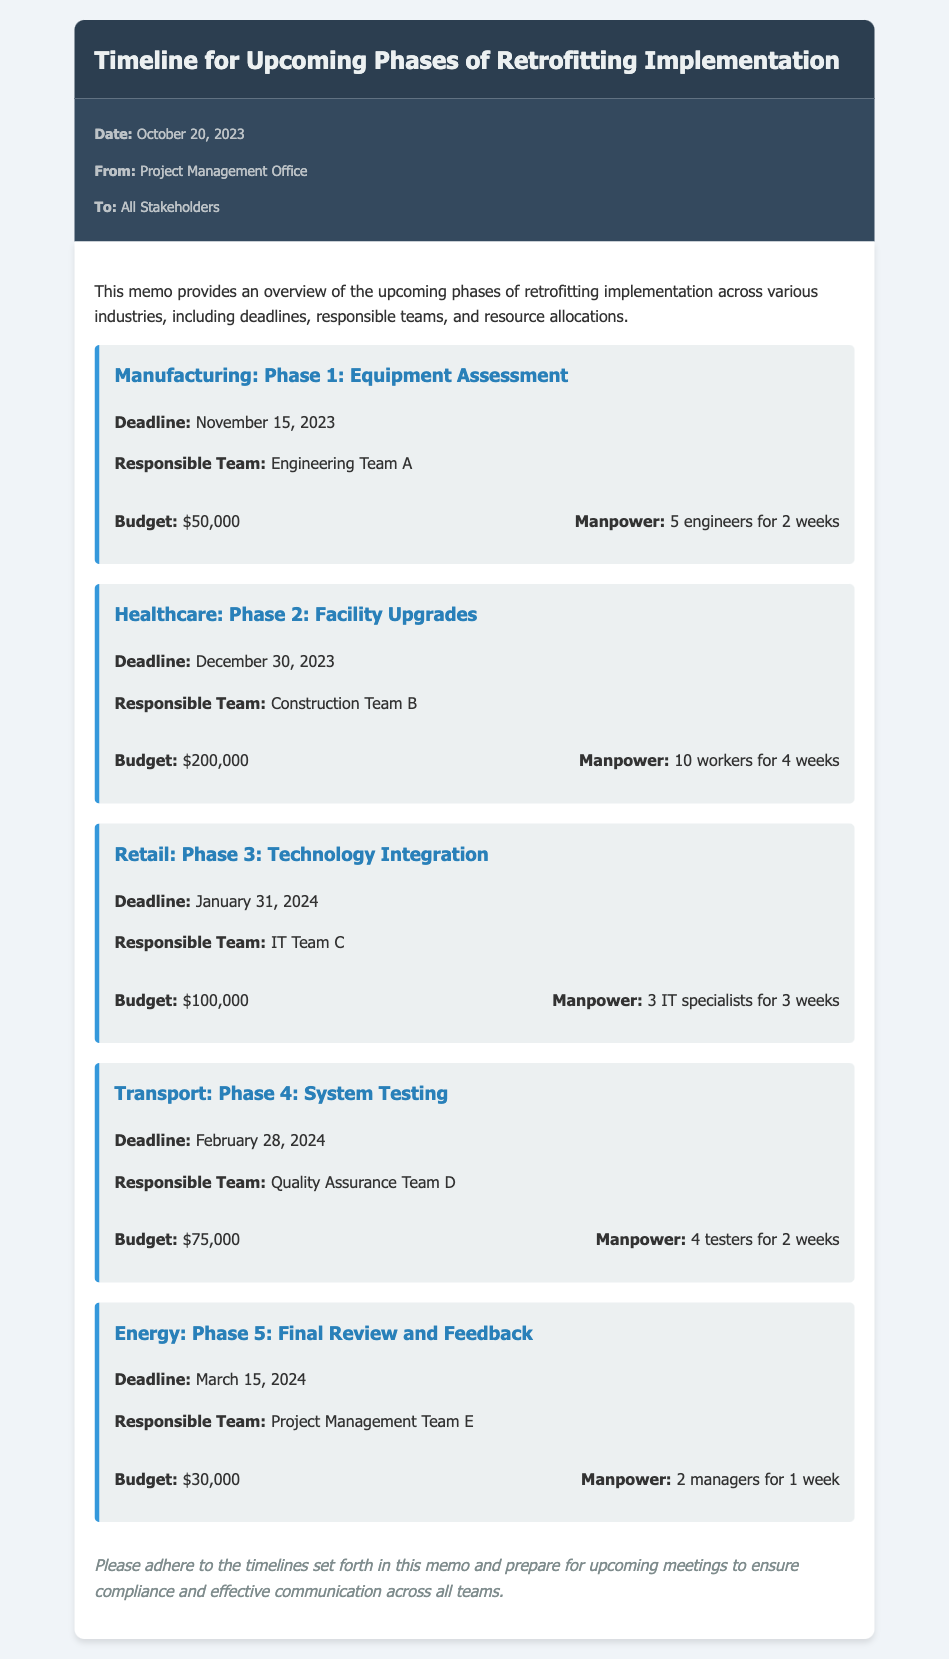What is the deadline for Manufacturing Phase 1? The deadline for Manufacturing Phase 1 is mentioned in the document as November 15, 2023.
Answer: November 15, 2023 Who is responsible for Healthcare Phase 2? The document states that the responsible team for Healthcare Phase 2 is Construction Team B.
Answer: Construction Team B What is the budget allocated for Retail Phase 3? According to the document, the budget allocated for Retail Phase 3 is $100,000.
Answer: $100,000 How many workers are allocated for Healthcare Phase 2? The document specifies that 10 workers are allocated for Healthcare Phase 2.
Answer: 10 workers What is the total manpower required for Energy Phase 5? The document indicates that 2 managers for 1 week are required for Energy Phase 5 as manpower.
Answer: 2 managers When is the final review and feedback scheduled? The document provides the deadline for the final review and feedback, which is March 15, 2024.
Answer: March 15, 2024 What is the budget for Transport Phase 4? The document details that the budget for Transport Phase 4 is $75,000.
Answer: $75,000 Which team is responsible for System Testing in Transport Phase 4? The document states that Quality Assurance Team D is responsible for System Testing in Transport Phase 4.
Answer: Quality Assurance Team D What is the conclusion given in the memo? The conclusion emphasizes adherence to timelines and preparation for upcoming meetings as mentioned in the memo.
Answer: Please adhere to the timelines set forth in this memo and prepare for upcoming meetings to ensure compliance and effective communication across all teams 